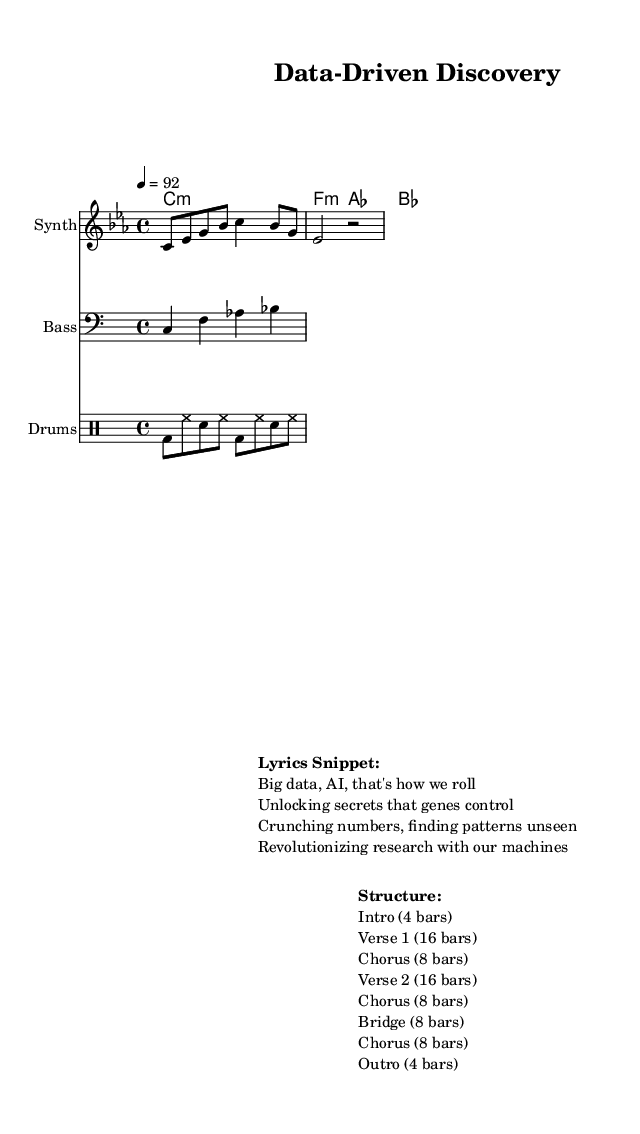What is the key signature of this music? The key signature is C minor, as indicated by the information in the 'global' section of the code, which states "\key c \minor."
Answer: C minor What is the time signature of the piece? The time signature is 4/4, found in the 'global' section indicating it follows a standard four beats per measure format.
Answer: 4/4 What is the tempo marking for this piece? The tempo marking is 92 beats per minute, shown in the 'global' section with "\tempo 4 = 92."
Answer: 92 How many bars are in Verse 1? Verse 1 contains 16 bars, as outlined in the structure of the lyrics snippet under "Structure."
Answer: 16 bars What instruments are used in the arrangement? The instruments used are Synth, Bass, and Drums, clear from the instrument names specified in the score sections for each staff.
Answer: Synth, Bass, Drums What theme is highlighted in the lyrics snippet? The theme highlighted is the use of big data and AI in scientific research, as derived from the lines mentioning unlocking genetic secrets and revolutionizing research.
Answer: Big data and AI in genetic research What section follows the Chorus in the structure? The section that follows the Chorus is the Bridge, as indicated in the specified structure arrangement outlined in the lyrics snippet.
Answer: Bridge 